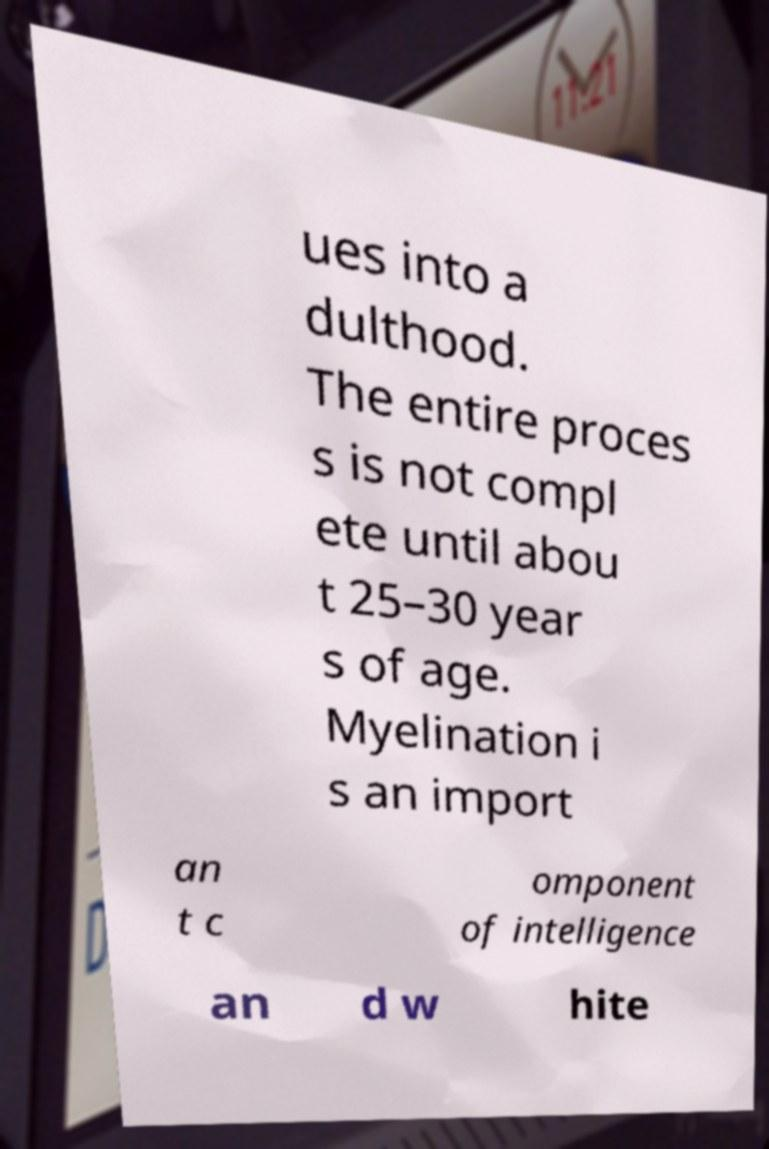Please read and relay the text visible in this image. What does it say? ues into a dulthood. The entire proces s is not compl ete until abou t 25–30 year s of age. Myelination i s an import an t c omponent of intelligence an d w hite 